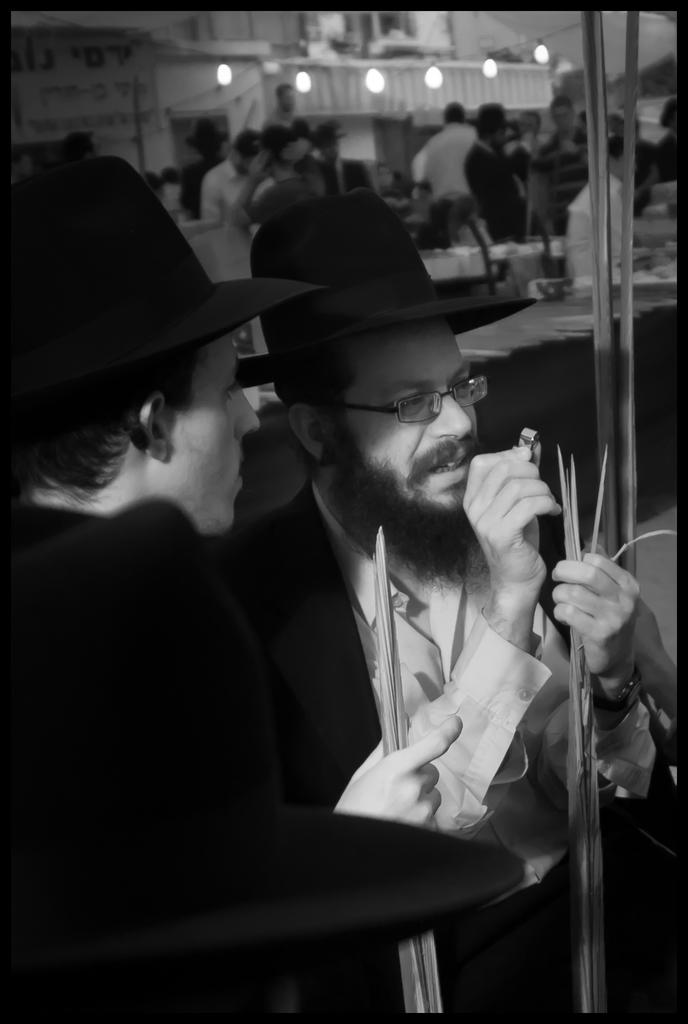How many people are present in the image? There are two persons in the image. What are the persons wearing on their heads? The persons are wearing hats. What are the persons holding in their hands? The persons are holding objects. What can be seen in the background of the image? There are people, tables, and lights associated with buildings visible in the background of the image. What type of polish is being applied to the dock in the image? There is no dock or polish present in the image. How many dogs are visible in the image? There are no dogs visible in the image. 